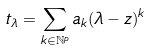<formula> <loc_0><loc_0><loc_500><loc_500>t _ { \lambda } = \sum _ { k \in \mathbb { N } ^ { p } } a _ { k } ( \lambda - z ) ^ { k }</formula> 